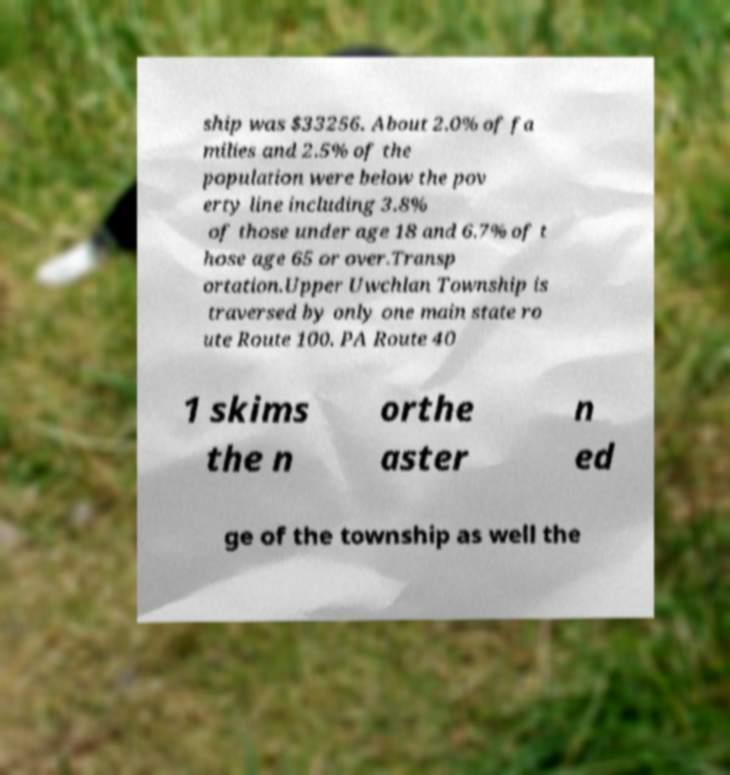What messages or text are displayed in this image? I need them in a readable, typed format. ship was $33256. About 2.0% of fa milies and 2.5% of the population were below the pov erty line including 3.8% of those under age 18 and 6.7% of t hose age 65 or over.Transp ortation.Upper Uwchlan Township is traversed by only one main state ro ute Route 100. PA Route 40 1 skims the n orthe aster n ed ge of the township as well the 